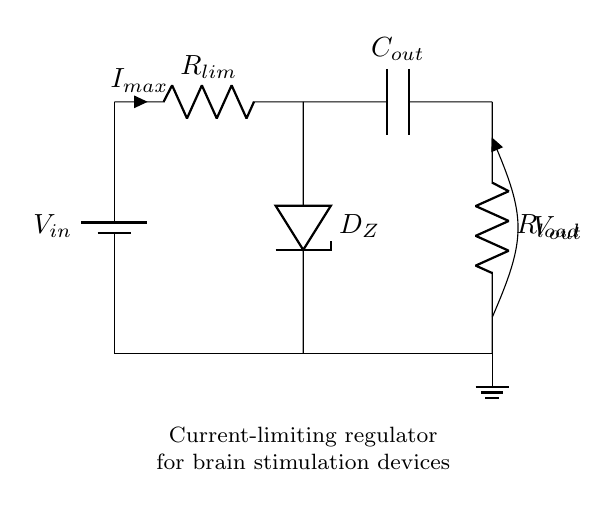What component is used to limit the current in this circuit? The current-limiting resistor is designated as "R_lim," which is specifically used to restrict the current flowing through the circuit to protect the load.
Answer: R_lim What does "D_Z" represent in the circuit? "D_Z" represents a Zener diode, which is included to regulate and maintain a consistent output voltage despite variations in the input voltage.
Answer: Zener diode What is the purpose of "C_out"? "C_out" is an output capacitor, which is designed to smooth the output voltage and reduce fluctuations, aiding in stable operation of the load.
Answer: Output capacitor What is the function of the load resistor, "R_load"? "R_load" represents the brain stimulation device load, serving as the component upon which the regulated voltage is applied to facilitate stimulation.
Answer: R_load What is the maximum current defined in the circuit? The maximum current is indicated by "I_max," which is the current that the regulator is set to limit to ensure the protection of the connected load.
Answer: I_max How do the components interact to ensure protection for the brain stimulation device? The interaction occurs as follows: the current-limiting resistor "R_lim" restricts the current flow, the Zener diode "D_Z" stabilizes the output voltage, and the capacitor "C_out" smooths the output, thereby ensuring that the brain stimulation device receives a secure and stable power supply.
Answer: R_lim, D_Z, C_out What is the voltage label at the output node? The output voltage is labeled as "V_out," representing the voltage provided to the load resistor "R_load" for the functioning of the connected device.
Answer: V_out 